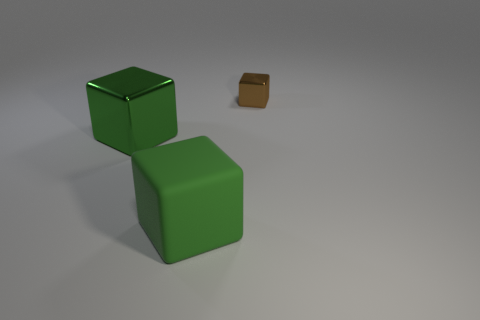What is the material of the green thing that is to the right of the metal thing left of the small brown metal thing behind the green metal block?
Provide a succinct answer. Rubber. There is another thing that is made of the same material as the brown thing; what shape is it?
Give a very brief answer. Cube. Is the material of the large block in front of the large green metallic cube the same as the block on the right side of the large rubber thing?
Provide a succinct answer. No. What color is the cube that is made of the same material as the small thing?
Your answer should be compact. Green. Do the big object left of the big rubber thing and the thing that is behind the large green shiny block have the same shape?
Your response must be concise. Yes. The shiny object that is the same size as the rubber thing is what shape?
Make the answer very short. Cube. Are there any other things that are the same shape as the brown thing?
Your response must be concise. Yes. Are the large green object that is behind the big green rubber block and the brown block made of the same material?
Provide a short and direct response. Yes. There is a block that is the same size as the green matte object; what is it made of?
Make the answer very short. Metal. How many other things are there of the same material as the brown thing?
Give a very brief answer. 1. 